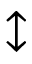<formula> <loc_0><loc_0><loc_500><loc_500>\updownarrow</formula> 